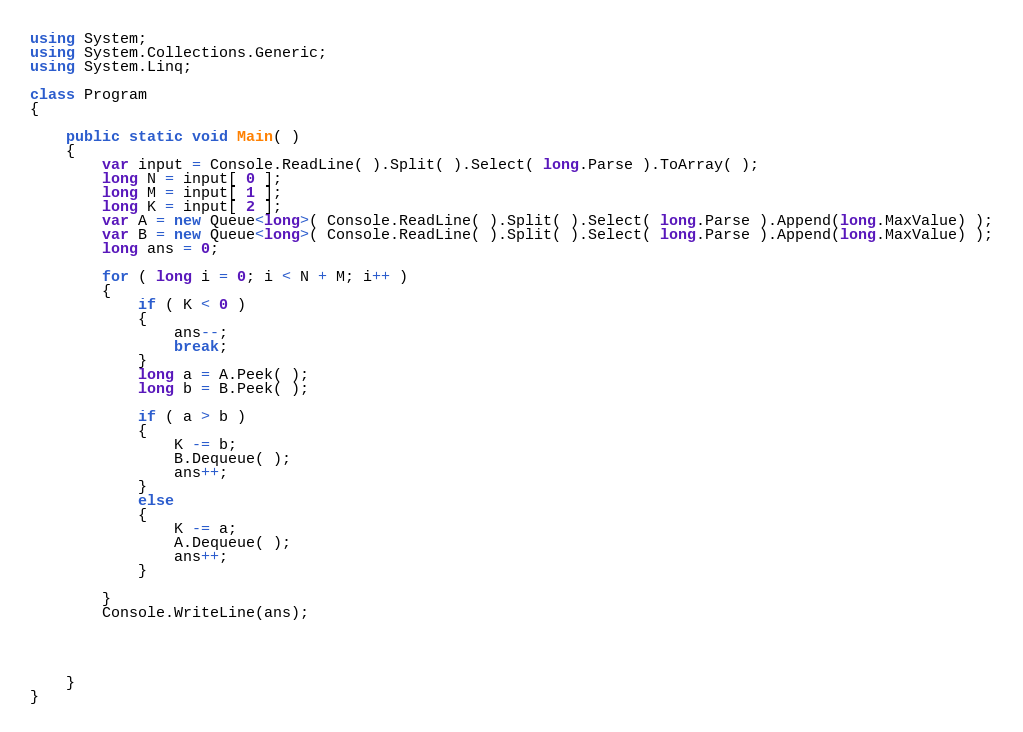<code> <loc_0><loc_0><loc_500><loc_500><_C#_>
using System;
using System.Collections.Generic;
using System.Linq;

class Program
{

    public static void Main( )
    {
        var input = Console.ReadLine( ).Split( ).Select( long.Parse ).ToArray( );
        long N = input[ 0 ];
        long M = input[ 1 ];
        long K = input[ 2 ];
        var A = new Queue<long>( Console.ReadLine( ).Split( ).Select( long.Parse ).Append(long.MaxValue) );
        var B = new Queue<long>( Console.ReadLine( ).Split( ).Select( long.Parse ).Append(long.MaxValue) );
        long ans = 0;

        for ( long i = 0; i < N + M; i++ )
        {
            if ( K < 0 )
            {
                ans--;
                break;
            }
            long a = A.Peek( );
            long b = B.Peek( );

            if ( a > b )
            {
                K -= b;
                B.Dequeue( );
                ans++;
            }
            else
            {
                K -= a;
                A.Dequeue( );
                ans++;
            }

        }
        Console.WriteLine(ans);




    }
}
</code> 